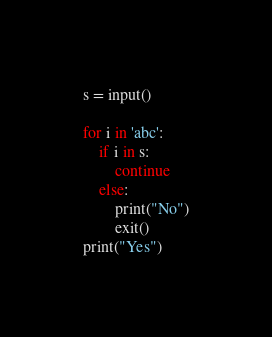Convert code to text. <code><loc_0><loc_0><loc_500><loc_500><_Python_>s = input()

for i in 'abc':
    if i in s:
        continue
    else:
        print("No")
        exit()
print("Yes")</code> 